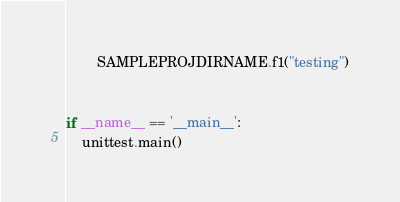<code> <loc_0><loc_0><loc_500><loc_500><_Python_>        SAMPLEPROJDIRNAME.f1("testing")


if __name__ == '__main__':
    unittest.main()
</code> 